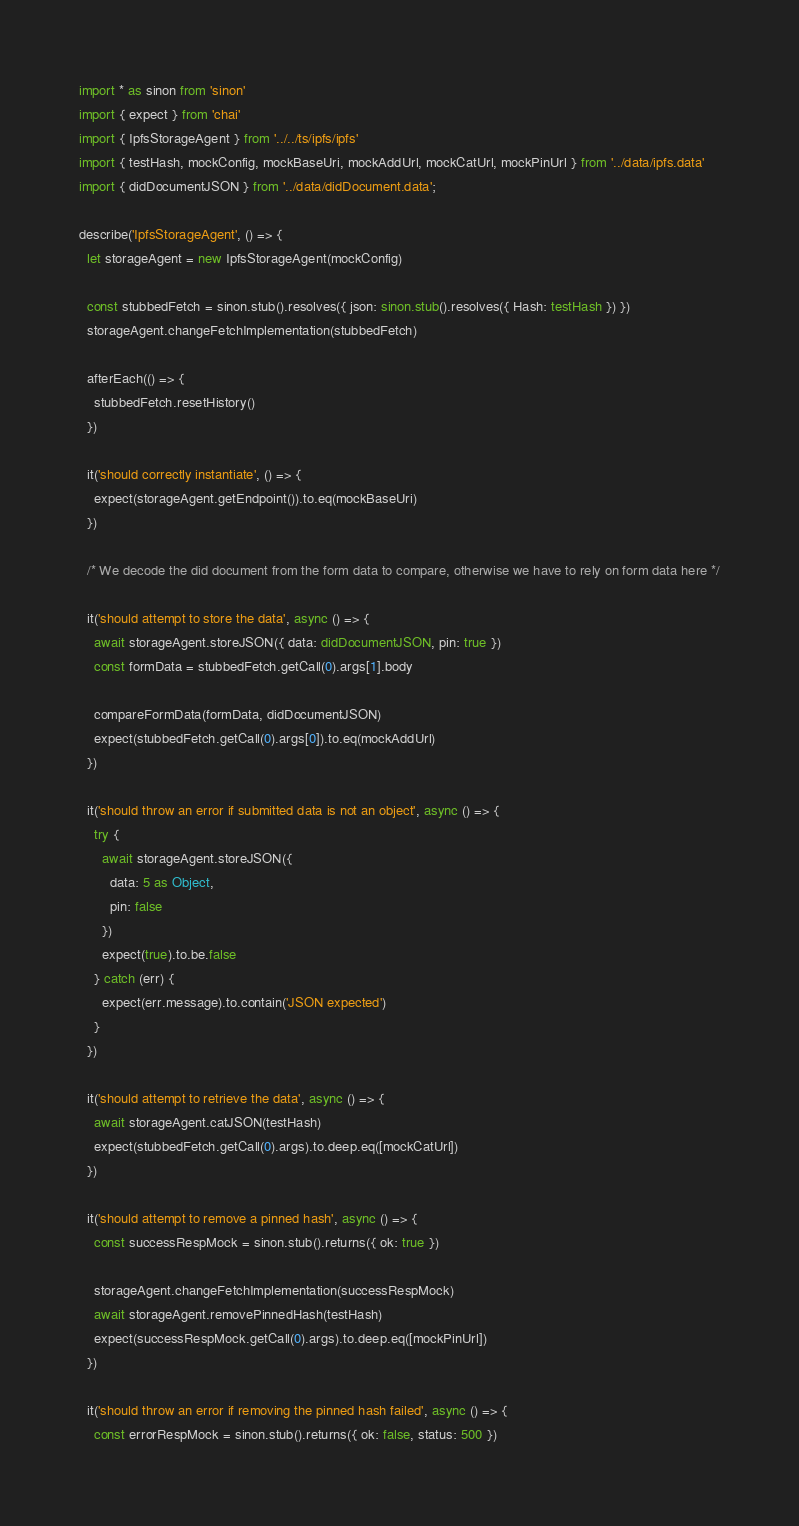<code> <loc_0><loc_0><loc_500><loc_500><_TypeScript_>import * as sinon from 'sinon'
import { expect } from 'chai'
import { IpfsStorageAgent } from '../../ts/ipfs/ipfs'
import { testHash, mockConfig, mockBaseUri, mockAddUrl, mockCatUrl, mockPinUrl } from '../data/ipfs.data'
import { didDocumentJSON } from '../data/didDocument.data';

describe('IpfsStorageAgent', () => {
  let storageAgent = new IpfsStorageAgent(mockConfig)

  const stubbedFetch = sinon.stub().resolves({ json: sinon.stub().resolves({ Hash: testHash }) })
  storageAgent.changeFetchImplementation(stubbedFetch)

  afterEach(() => {
    stubbedFetch.resetHistory()
  })

  it('should correctly instantiate', () => {
    expect(storageAgent.getEndpoint()).to.eq(mockBaseUri)
  })

  /* We decode the did document from the form data to compare, otherwise we have to rely on form data here */

  it('should attempt to store the data', async () => {
    await storageAgent.storeJSON({ data: didDocumentJSON, pin: true })
    const formData = stubbedFetch.getCall(0).args[1].body

    compareFormData(formData, didDocumentJSON)
    expect(stubbedFetch.getCall(0).args[0]).to.eq(mockAddUrl)
  })

  it('should throw an error if submitted data is not an object', async () => {
    try {
      await storageAgent.storeJSON({
        data: 5 as Object,
        pin: false
      })
      expect(true).to.be.false
    } catch (err) {
      expect(err.message).to.contain('JSON expected')
    }
  })

  it('should attempt to retrieve the data', async () => {
    await storageAgent.catJSON(testHash)
    expect(stubbedFetch.getCall(0).args).to.deep.eq([mockCatUrl])
  })

  it('should attempt to remove a pinned hash', async () => {
    const successRespMock = sinon.stub().returns({ ok: true })

    storageAgent.changeFetchImplementation(successRespMock)
    await storageAgent.removePinnedHash(testHash)
    expect(successRespMock.getCall(0).args).to.deep.eq([mockPinUrl])
  })

  it('should throw an error if removing the pinned hash failed', async () => {
    const errorRespMock = sinon.stub().returns({ ok: false, status: 500 })</code> 